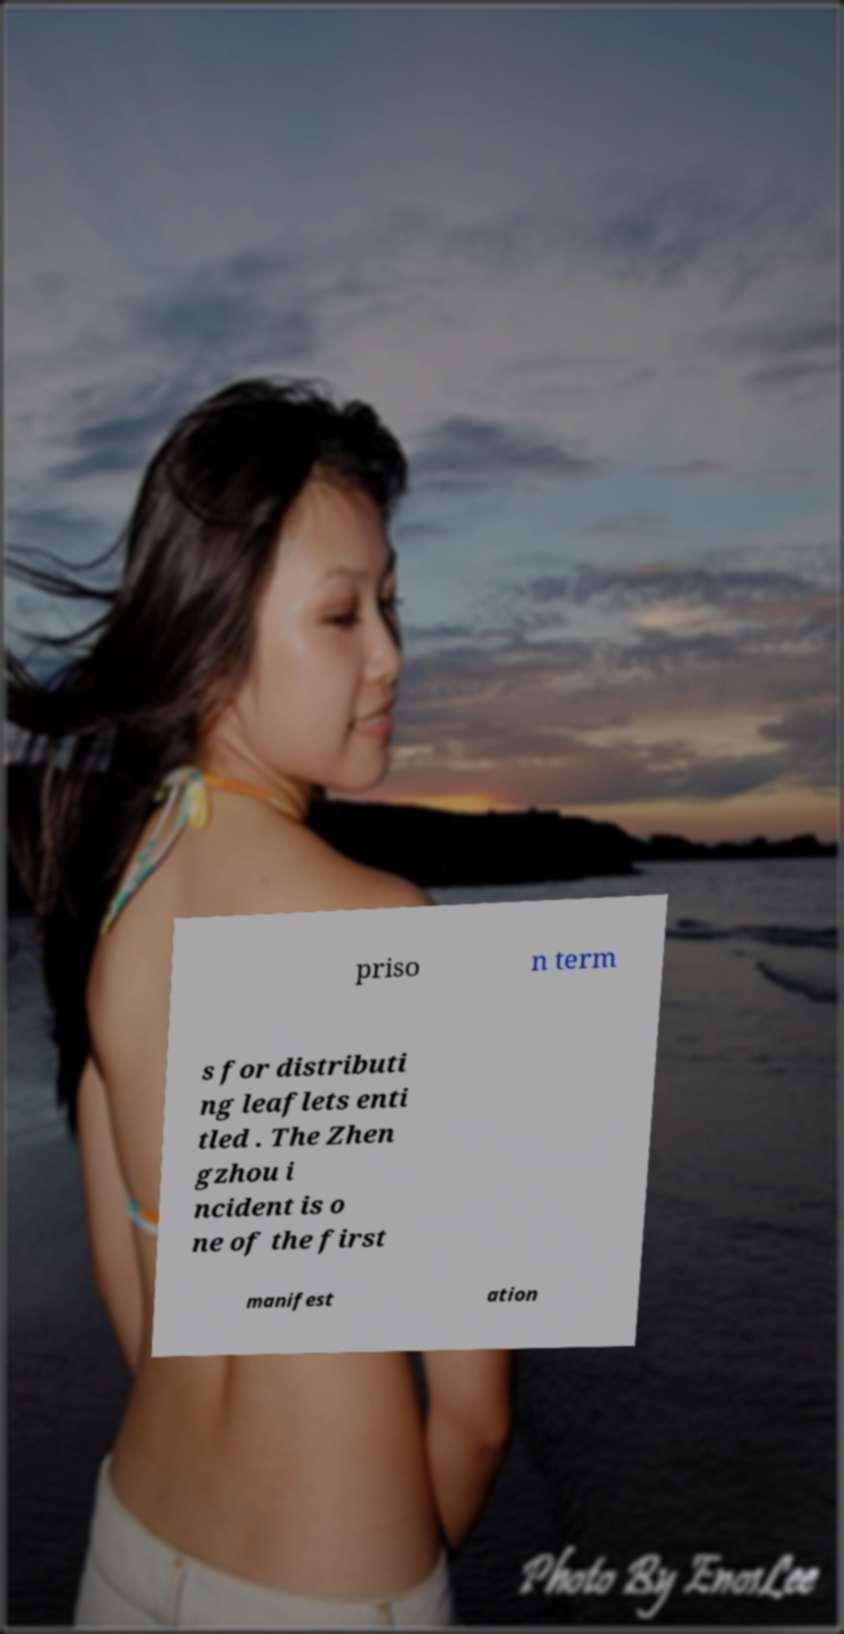I need the written content from this picture converted into text. Can you do that? priso n term s for distributi ng leaflets enti tled . The Zhen gzhou i ncident is o ne of the first manifest ation 